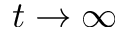<formula> <loc_0><loc_0><loc_500><loc_500>t \to \infty</formula> 